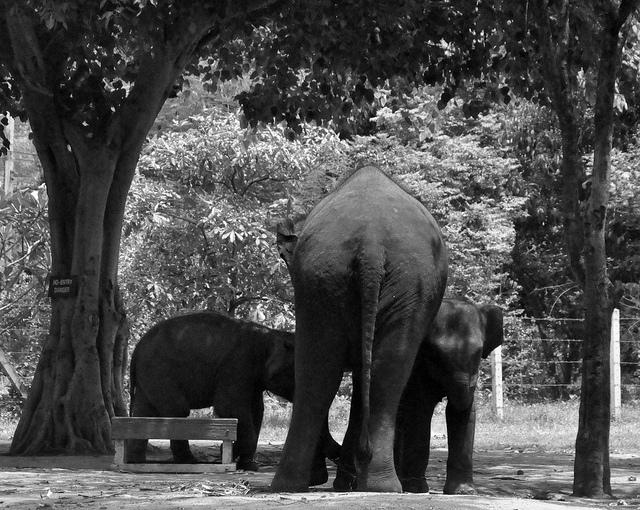What are the Elephants standing on?

Choices:
A) sticks
B) water
C) concrete
D) snow concrete 